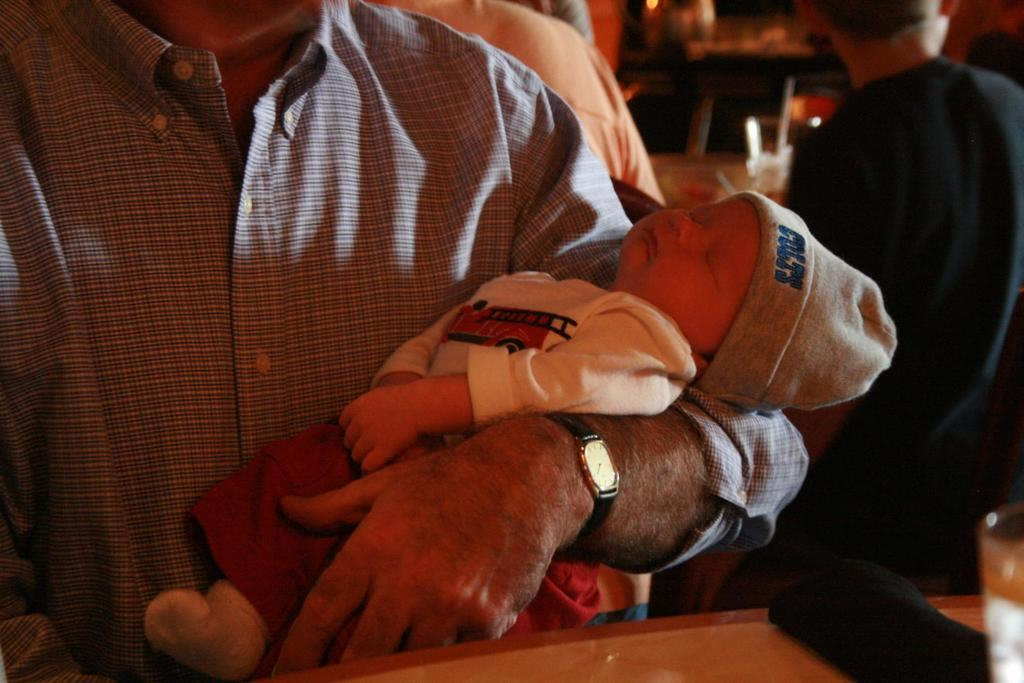Provide a one-sentence caption for the provided image. A man is holding an infant that has a COLTS hat on. 